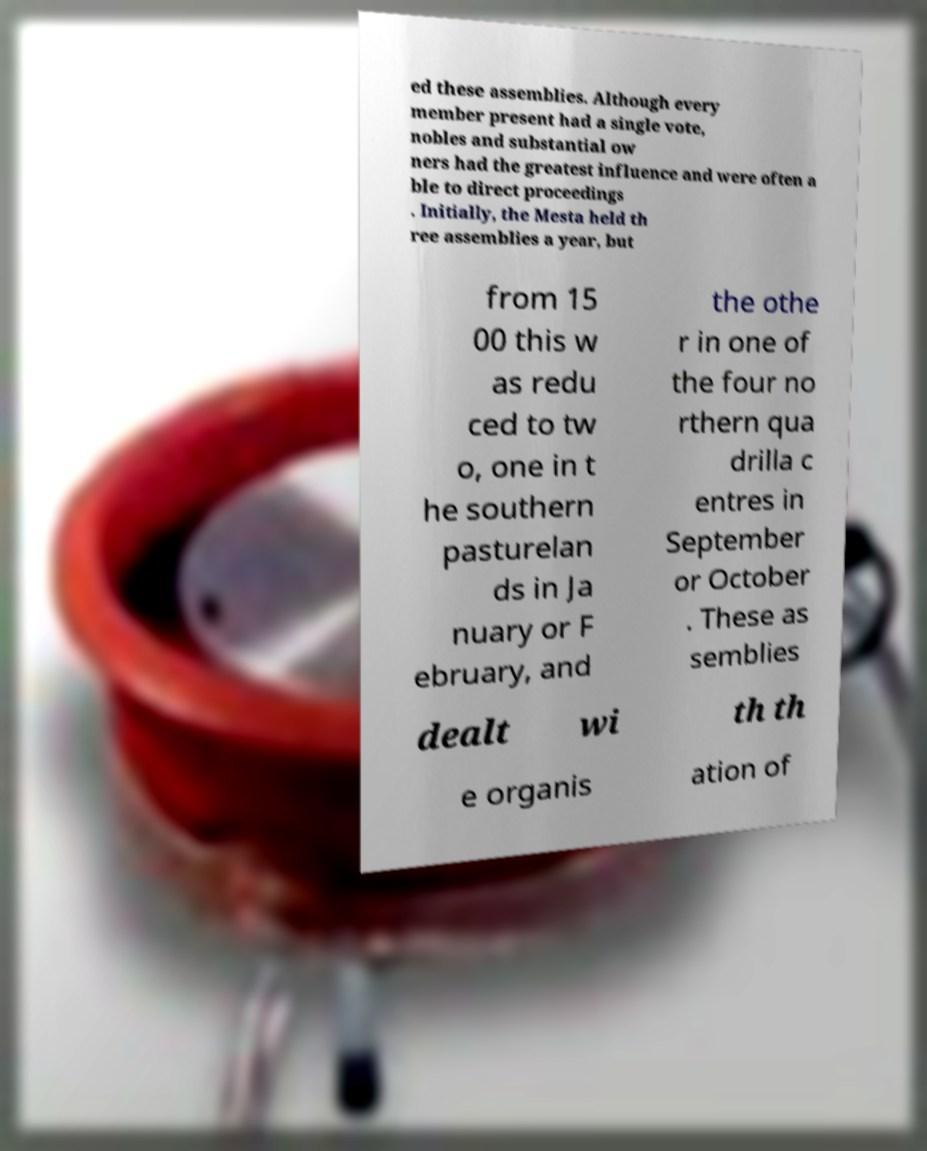Can you accurately transcribe the text from the provided image for me? ed these assemblies. Although every member present had a single vote, nobles and substantial ow ners had the greatest influence and were often a ble to direct proceedings . Initially, the Mesta held th ree assemblies a year, but from 15 00 this w as redu ced to tw o, one in t he southern pasturelan ds in Ja nuary or F ebruary, and the othe r in one of the four no rthern qua drilla c entres in September or October . These as semblies dealt wi th th e organis ation of 